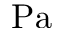<formula> <loc_0><loc_0><loc_500><loc_500>P a</formula> 